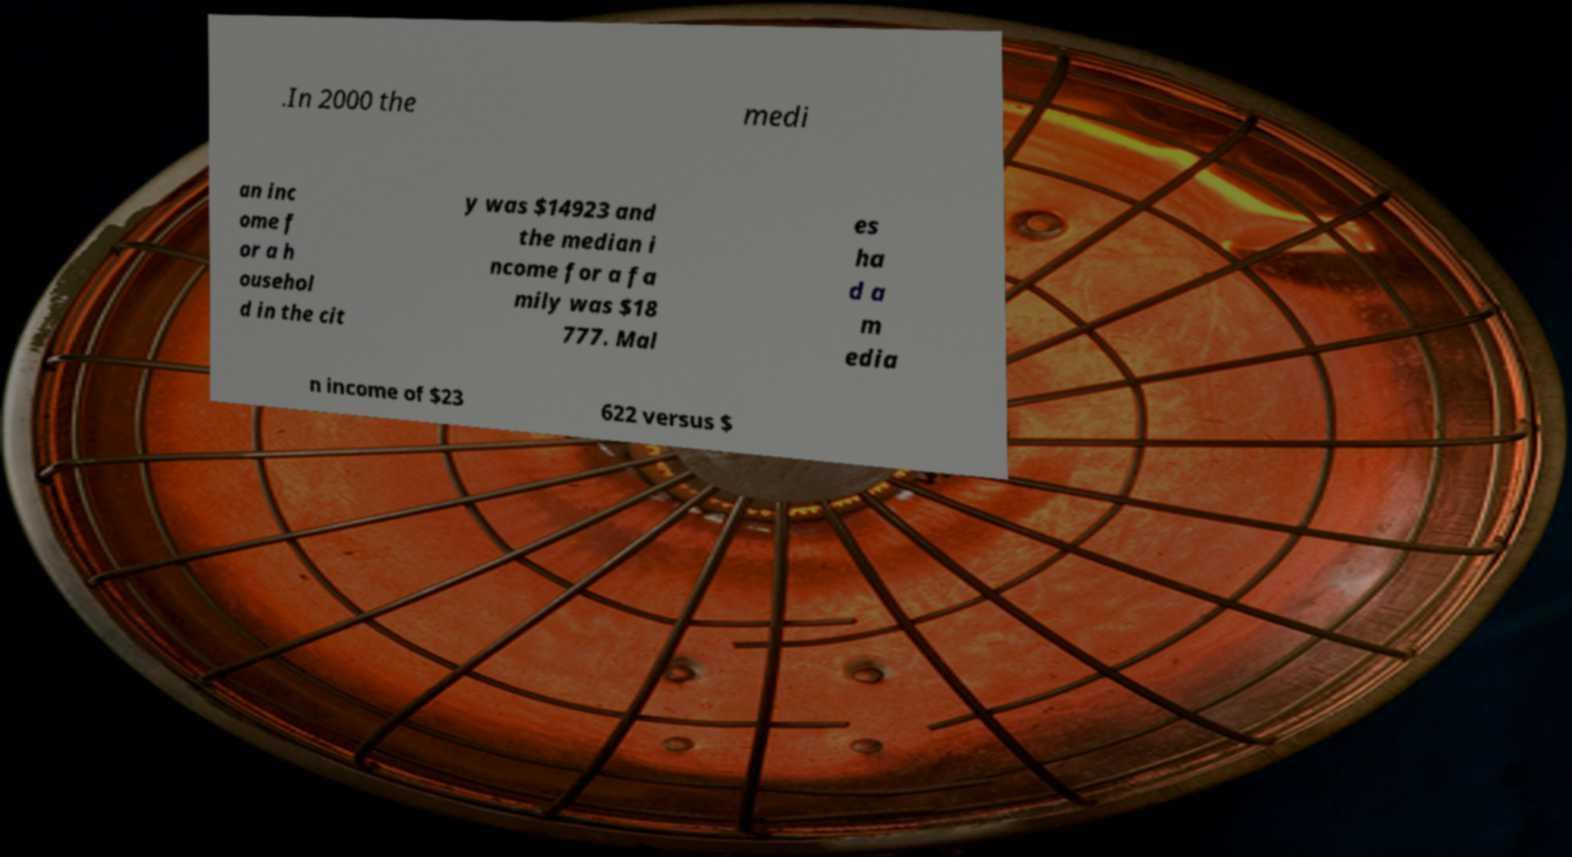Can you accurately transcribe the text from the provided image for me? .In 2000 the medi an inc ome f or a h ousehol d in the cit y was $14923 and the median i ncome for a fa mily was $18 777. Mal es ha d a m edia n income of $23 622 versus $ 